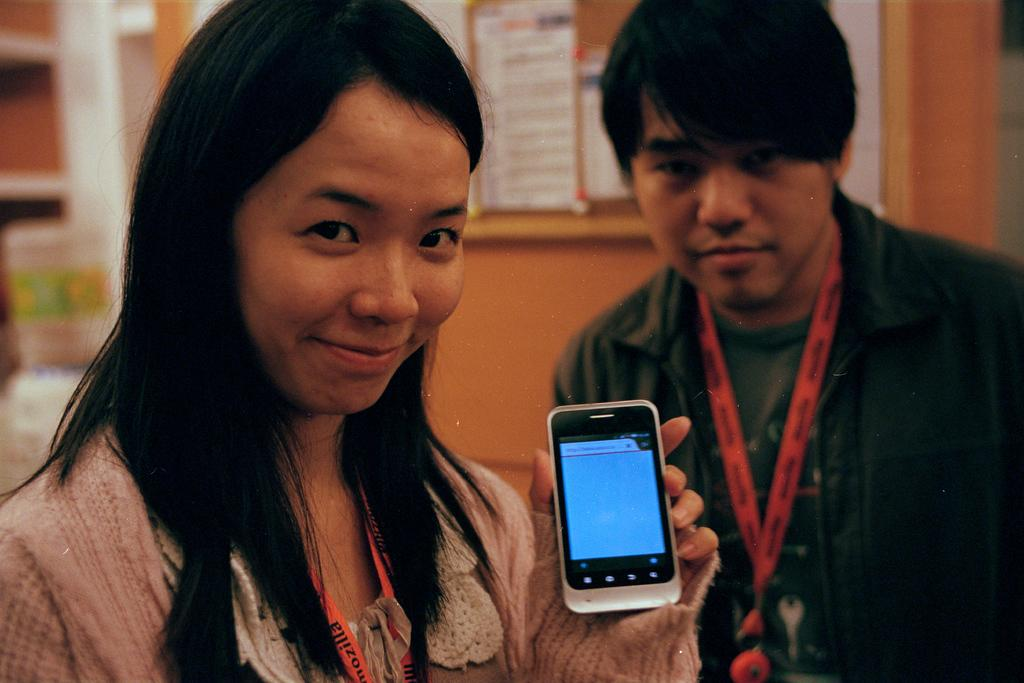What is the woman in the image holding? The woman is holding a mobile in the image. What is the woman's facial expression in the image? The woman is smiling in the image. Who else is present in the image? There is a man in the image. What can be seen on the wall in the image? There are papers on the wall in the image. What is the notice board used for in the image? The notice board is used for displaying information or announcements in the image. How many trees can be seen in the image? There are no trees visible in the image. What type of beast is present in the image? There is no beast present in the image. 